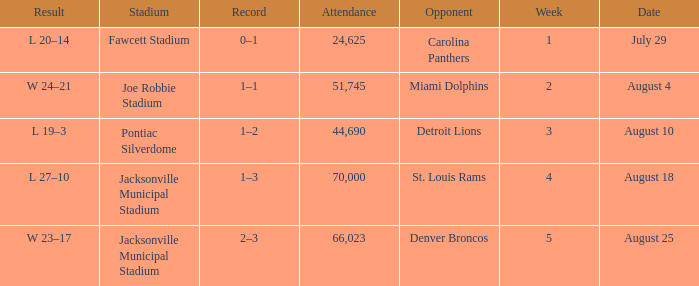WHEN has a Opponent of miami dolphins? August 4. 